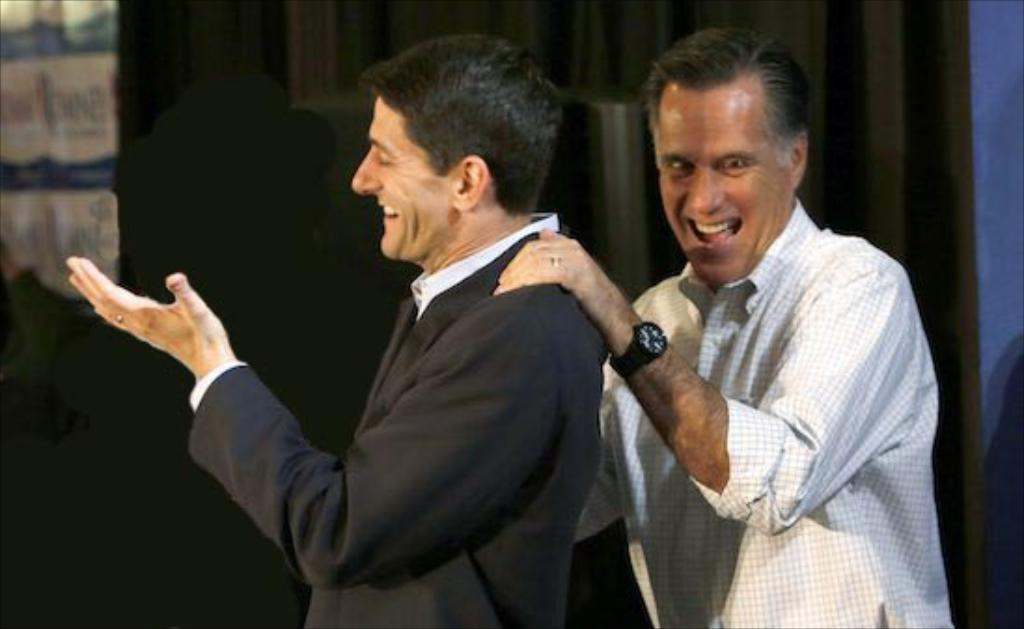How many people are in the image? There are two persons in the image. What are the persons doing in the image? The persons are standing and smiling. Can you describe the background of the image? There are objects in the background of the image. What type of hole can be seen in the image? There is no hole present in the image. What color are the teeth of the persons in the image? The image does not show the persons' teeth, so we cannot determine their color. 